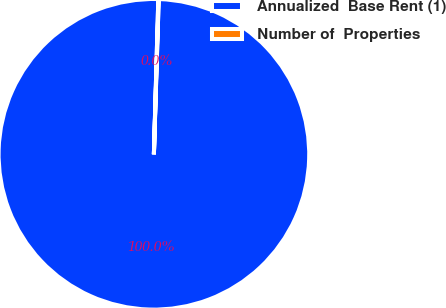<chart> <loc_0><loc_0><loc_500><loc_500><pie_chart><fcel>Annualized  Base Rent (1)<fcel>Number of  Properties<nl><fcel>99.96%<fcel>0.04%<nl></chart> 